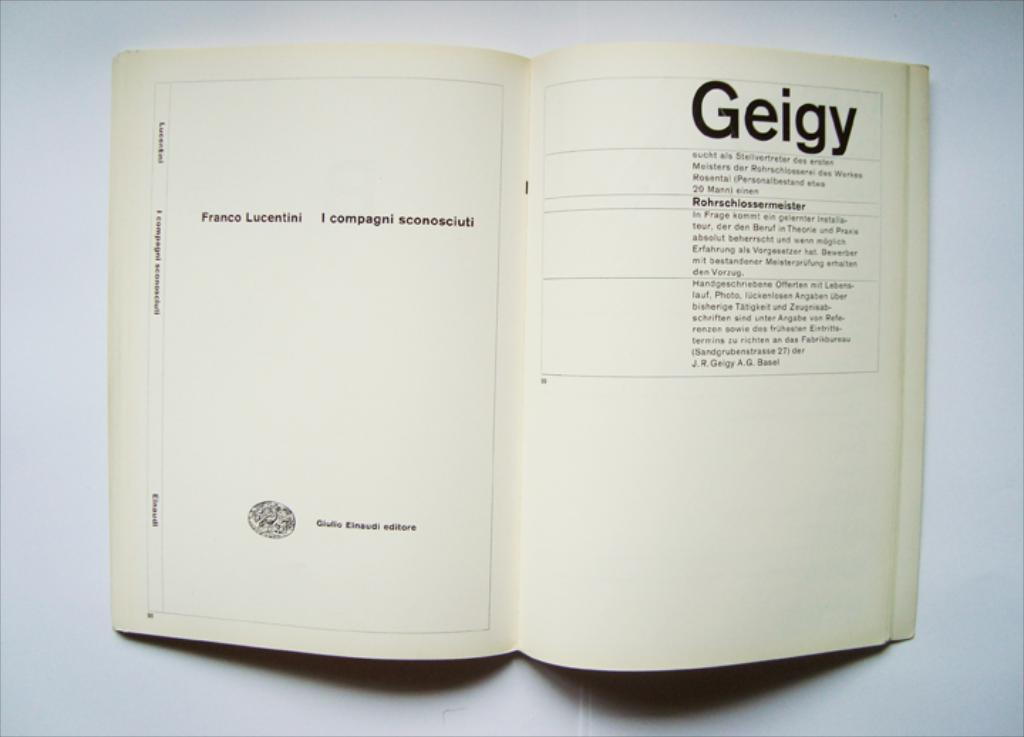<image>
Relay a brief, clear account of the picture shown. A white open book with the word geigy written as the heading on a page. 